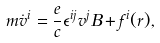Convert formula to latex. <formula><loc_0><loc_0><loc_500><loc_500>m \dot { v } ^ { i } = \frac { e } { c } \epsilon ^ { i j } v ^ { j } B + f ^ { i } ( { r } ) ,</formula> 